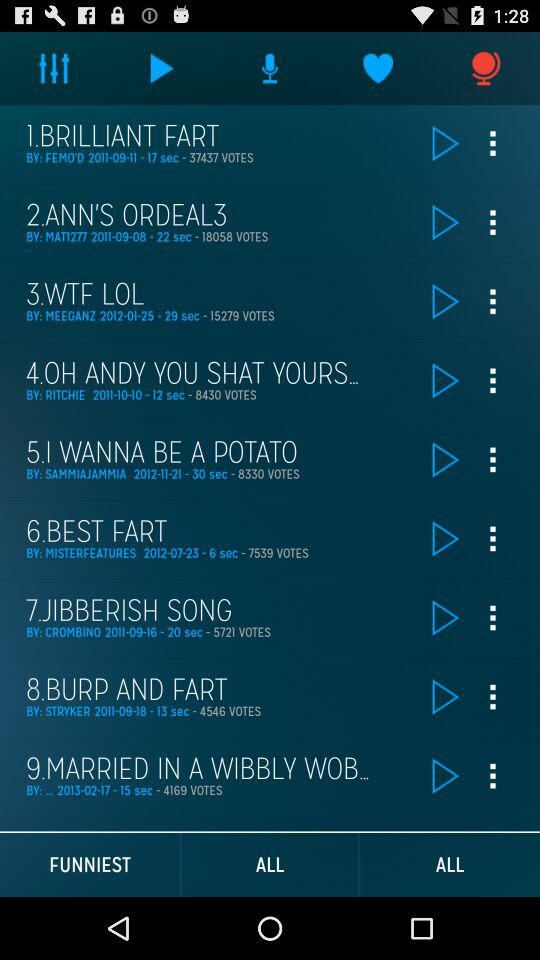Who is the singer of Brilliant Fart? The singer is "FEMO'D". 